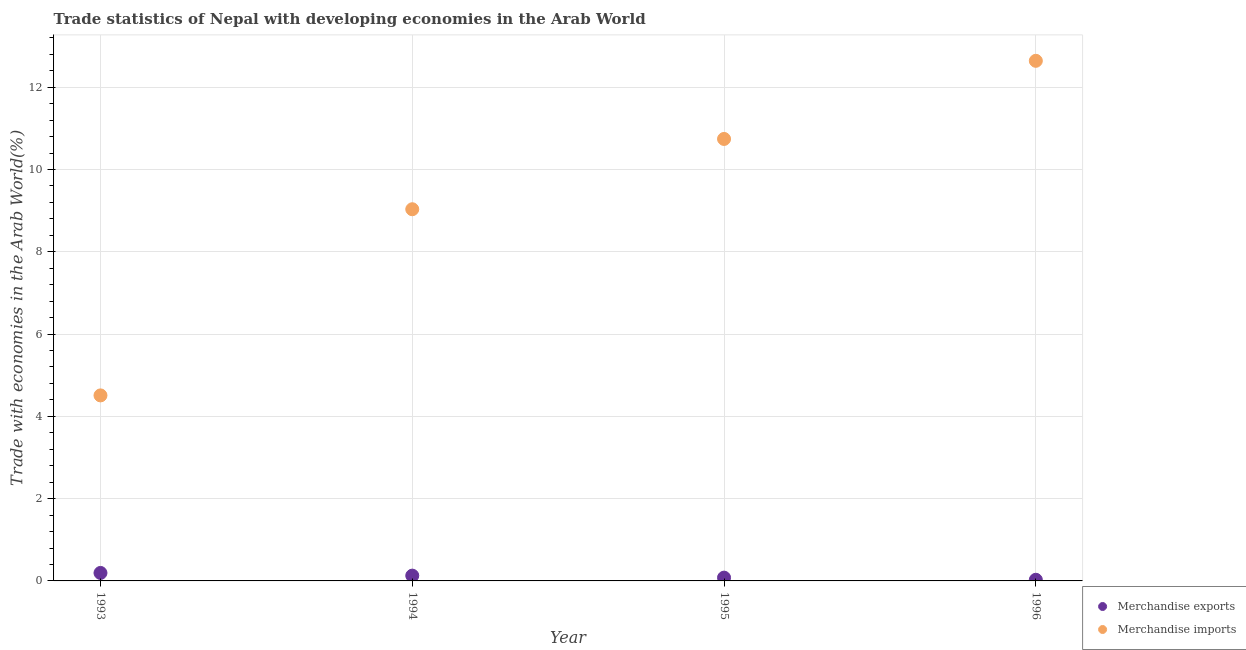What is the merchandise imports in 1994?
Provide a succinct answer. 9.03. Across all years, what is the maximum merchandise exports?
Keep it short and to the point. 0.19. Across all years, what is the minimum merchandise imports?
Provide a short and direct response. 4.51. In which year was the merchandise exports maximum?
Ensure brevity in your answer.  1993. What is the total merchandise exports in the graph?
Give a very brief answer. 0.43. What is the difference between the merchandise imports in 1993 and that in 1996?
Your answer should be compact. -8.13. What is the difference between the merchandise exports in 1994 and the merchandise imports in 1996?
Offer a terse response. -12.51. What is the average merchandise imports per year?
Provide a succinct answer. 9.23. In the year 1995, what is the difference between the merchandise imports and merchandise exports?
Provide a succinct answer. 10.66. What is the ratio of the merchandise exports in 1993 to that in 1996?
Provide a short and direct response. 6.99. What is the difference between the highest and the second highest merchandise exports?
Your answer should be compact. 0.07. What is the difference between the highest and the lowest merchandise exports?
Offer a terse response. 0.17. Is the sum of the merchandise exports in 1994 and 1996 greater than the maximum merchandise imports across all years?
Make the answer very short. No. Does the merchandise imports monotonically increase over the years?
Provide a succinct answer. Yes. Is the merchandise imports strictly less than the merchandise exports over the years?
Your answer should be very brief. No. How many dotlines are there?
Your response must be concise. 2. How many years are there in the graph?
Provide a short and direct response. 4. What is the difference between two consecutive major ticks on the Y-axis?
Offer a very short reply. 2. Are the values on the major ticks of Y-axis written in scientific E-notation?
Your answer should be very brief. No. Does the graph contain grids?
Ensure brevity in your answer.  Yes. Where does the legend appear in the graph?
Keep it short and to the point. Bottom right. How are the legend labels stacked?
Provide a short and direct response. Vertical. What is the title of the graph?
Offer a very short reply. Trade statistics of Nepal with developing economies in the Arab World. What is the label or title of the Y-axis?
Your answer should be compact. Trade with economies in the Arab World(%). What is the Trade with economies in the Arab World(%) in Merchandise exports in 1993?
Offer a terse response. 0.19. What is the Trade with economies in the Arab World(%) in Merchandise imports in 1993?
Ensure brevity in your answer.  4.51. What is the Trade with economies in the Arab World(%) in Merchandise exports in 1994?
Your answer should be very brief. 0.13. What is the Trade with economies in the Arab World(%) of Merchandise imports in 1994?
Give a very brief answer. 9.03. What is the Trade with economies in the Arab World(%) of Merchandise exports in 1995?
Provide a succinct answer. 0.08. What is the Trade with economies in the Arab World(%) of Merchandise imports in 1995?
Provide a succinct answer. 10.74. What is the Trade with economies in the Arab World(%) of Merchandise exports in 1996?
Offer a very short reply. 0.03. What is the Trade with economies in the Arab World(%) of Merchandise imports in 1996?
Your answer should be very brief. 12.64. Across all years, what is the maximum Trade with economies in the Arab World(%) of Merchandise exports?
Offer a terse response. 0.19. Across all years, what is the maximum Trade with economies in the Arab World(%) in Merchandise imports?
Keep it short and to the point. 12.64. Across all years, what is the minimum Trade with economies in the Arab World(%) in Merchandise exports?
Offer a very short reply. 0.03. Across all years, what is the minimum Trade with economies in the Arab World(%) in Merchandise imports?
Your answer should be compact. 4.51. What is the total Trade with economies in the Arab World(%) in Merchandise exports in the graph?
Give a very brief answer. 0.43. What is the total Trade with economies in the Arab World(%) of Merchandise imports in the graph?
Offer a very short reply. 36.93. What is the difference between the Trade with economies in the Arab World(%) in Merchandise exports in 1993 and that in 1994?
Offer a terse response. 0.07. What is the difference between the Trade with economies in the Arab World(%) in Merchandise imports in 1993 and that in 1994?
Provide a short and direct response. -4.53. What is the difference between the Trade with economies in the Arab World(%) of Merchandise exports in 1993 and that in 1995?
Give a very brief answer. 0.11. What is the difference between the Trade with economies in the Arab World(%) in Merchandise imports in 1993 and that in 1995?
Offer a terse response. -6.23. What is the difference between the Trade with economies in the Arab World(%) of Merchandise exports in 1993 and that in 1996?
Your answer should be very brief. 0.17. What is the difference between the Trade with economies in the Arab World(%) in Merchandise imports in 1993 and that in 1996?
Provide a succinct answer. -8.13. What is the difference between the Trade with economies in the Arab World(%) in Merchandise exports in 1994 and that in 1995?
Your answer should be very brief. 0.05. What is the difference between the Trade with economies in the Arab World(%) in Merchandise imports in 1994 and that in 1995?
Keep it short and to the point. -1.71. What is the difference between the Trade with economies in the Arab World(%) in Merchandise exports in 1994 and that in 1996?
Give a very brief answer. 0.1. What is the difference between the Trade with economies in the Arab World(%) in Merchandise imports in 1994 and that in 1996?
Provide a short and direct response. -3.61. What is the difference between the Trade with economies in the Arab World(%) of Merchandise exports in 1995 and that in 1996?
Ensure brevity in your answer.  0.05. What is the difference between the Trade with economies in the Arab World(%) of Merchandise imports in 1995 and that in 1996?
Your answer should be very brief. -1.9. What is the difference between the Trade with economies in the Arab World(%) of Merchandise exports in 1993 and the Trade with economies in the Arab World(%) of Merchandise imports in 1994?
Give a very brief answer. -8.84. What is the difference between the Trade with economies in the Arab World(%) in Merchandise exports in 1993 and the Trade with economies in the Arab World(%) in Merchandise imports in 1995?
Your answer should be very brief. -10.55. What is the difference between the Trade with economies in the Arab World(%) in Merchandise exports in 1993 and the Trade with economies in the Arab World(%) in Merchandise imports in 1996?
Your response must be concise. -12.45. What is the difference between the Trade with economies in the Arab World(%) of Merchandise exports in 1994 and the Trade with economies in the Arab World(%) of Merchandise imports in 1995?
Provide a short and direct response. -10.61. What is the difference between the Trade with economies in the Arab World(%) of Merchandise exports in 1994 and the Trade with economies in the Arab World(%) of Merchandise imports in 1996?
Your answer should be compact. -12.51. What is the difference between the Trade with economies in the Arab World(%) of Merchandise exports in 1995 and the Trade with economies in the Arab World(%) of Merchandise imports in 1996?
Ensure brevity in your answer.  -12.56. What is the average Trade with economies in the Arab World(%) in Merchandise exports per year?
Offer a terse response. 0.11. What is the average Trade with economies in the Arab World(%) of Merchandise imports per year?
Provide a succinct answer. 9.23. In the year 1993, what is the difference between the Trade with economies in the Arab World(%) in Merchandise exports and Trade with economies in the Arab World(%) in Merchandise imports?
Make the answer very short. -4.32. In the year 1994, what is the difference between the Trade with economies in the Arab World(%) of Merchandise exports and Trade with economies in the Arab World(%) of Merchandise imports?
Your answer should be compact. -8.91. In the year 1995, what is the difference between the Trade with economies in the Arab World(%) in Merchandise exports and Trade with economies in the Arab World(%) in Merchandise imports?
Your answer should be compact. -10.66. In the year 1996, what is the difference between the Trade with economies in the Arab World(%) in Merchandise exports and Trade with economies in the Arab World(%) in Merchandise imports?
Your answer should be compact. -12.61. What is the ratio of the Trade with economies in the Arab World(%) in Merchandise exports in 1993 to that in 1994?
Your answer should be very brief. 1.51. What is the ratio of the Trade with economies in the Arab World(%) in Merchandise imports in 1993 to that in 1994?
Offer a terse response. 0.5. What is the ratio of the Trade with economies in the Arab World(%) of Merchandise exports in 1993 to that in 1995?
Make the answer very short. 2.43. What is the ratio of the Trade with economies in the Arab World(%) of Merchandise imports in 1993 to that in 1995?
Your response must be concise. 0.42. What is the ratio of the Trade with economies in the Arab World(%) of Merchandise exports in 1993 to that in 1996?
Provide a succinct answer. 6.99. What is the ratio of the Trade with economies in the Arab World(%) in Merchandise imports in 1993 to that in 1996?
Your response must be concise. 0.36. What is the ratio of the Trade with economies in the Arab World(%) in Merchandise exports in 1994 to that in 1995?
Offer a terse response. 1.61. What is the ratio of the Trade with economies in the Arab World(%) of Merchandise imports in 1994 to that in 1995?
Your response must be concise. 0.84. What is the ratio of the Trade with economies in the Arab World(%) of Merchandise exports in 1994 to that in 1996?
Provide a succinct answer. 4.63. What is the ratio of the Trade with economies in the Arab World(%) of Merchandise imports in 1994 to that in 1996?
Provide a short and direct response. 0.71. What is the ratio of the Trade with economies in the Arab World(%) of Merchandise exports in 1995 to that in 1996?
Make the answer very short. 2.87. What is the ratio of the Trade with economies in the Arab World(%) in Merchandise imports in 1995 to that in 1996?
Your answer should be very brief. 0.85. What is the difference between the highest and the second highest Trade with economies in the Arab World(%) of Merchandise exports?
Your answer should be compact. 0.07. What is the difference between the highest and the second highest Trade with economies in the Arab World(%) of Merchandise imports?
Your answer should be compact. 1.9. What is the difference between the highest and the lowest Trade with economies in the Arab World(%) of Merchandise exports?
Offer a very short reply. 0.17. What is the difference between the highest and the lowest Trade with economies in the Arab World(%) of Merchandise imports?
Provide a short and direct response. 8.13. 